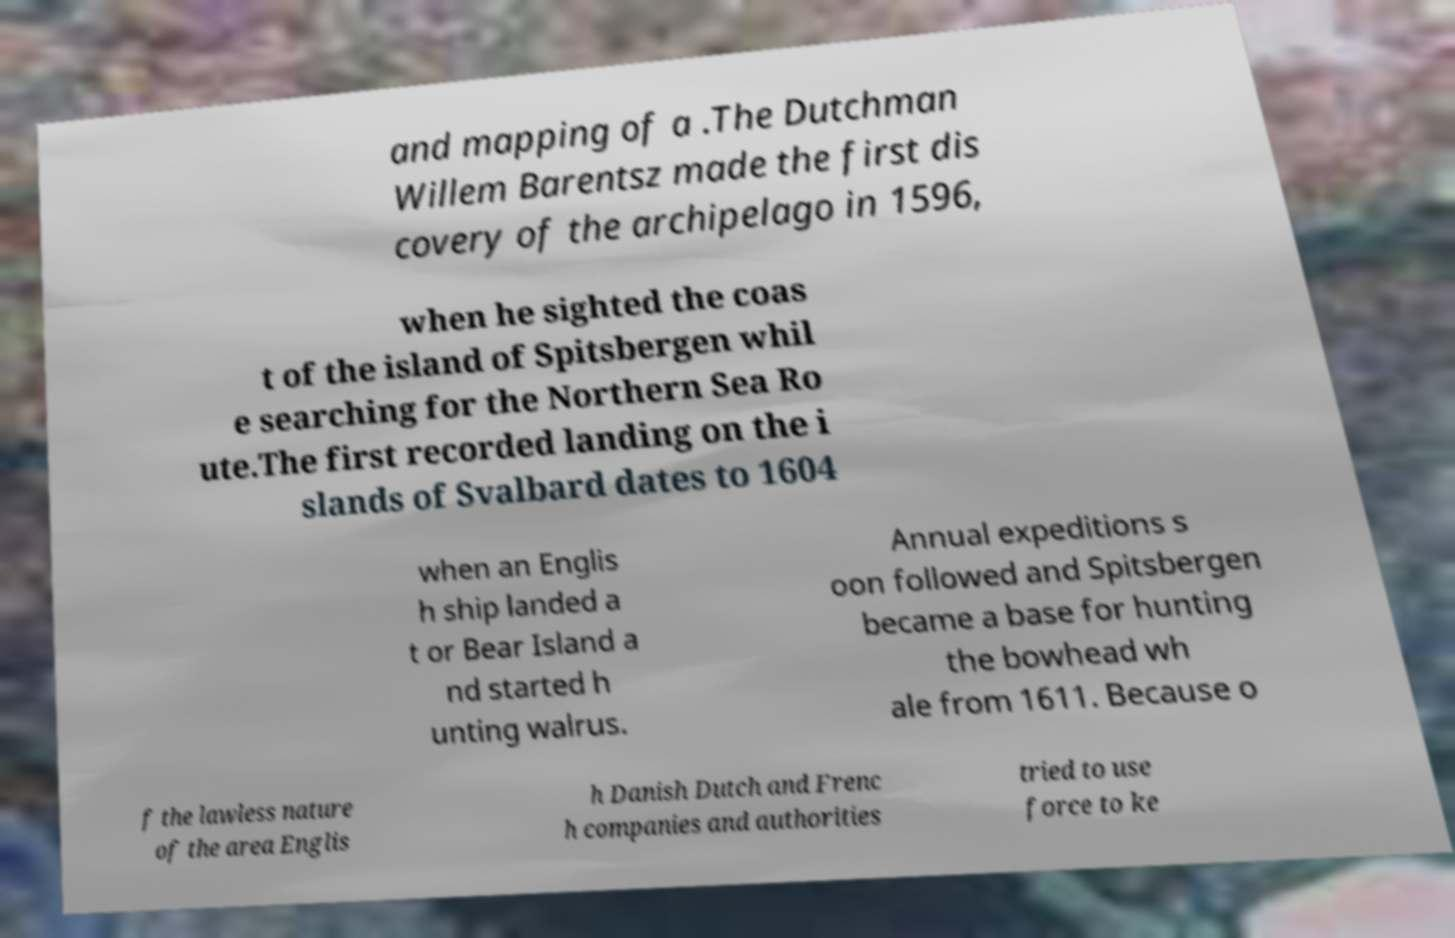Could you assist in decoding the text presented in this image and type it out clearly? and mapping of a .The Dutchman Willem Barentsz made the first dis covery of the archipelago in 1596, when he sighted the coas t of the island of Spitsbergen whil e searching for the Northern Sea Ro ute.The first recorded landing on the i slands of Svalbard dates to 1604 when an Englis h ship landed a t or Bear Island a nd started h unting walrus. Annual expeditions s oon followed and Spitsbergen became a base for hunting the bowhead wh ale from 1611. Because o f the lawless nature of the area Englis h Danish Dutch and Frenc h companies and authorities tried to use force to ke 